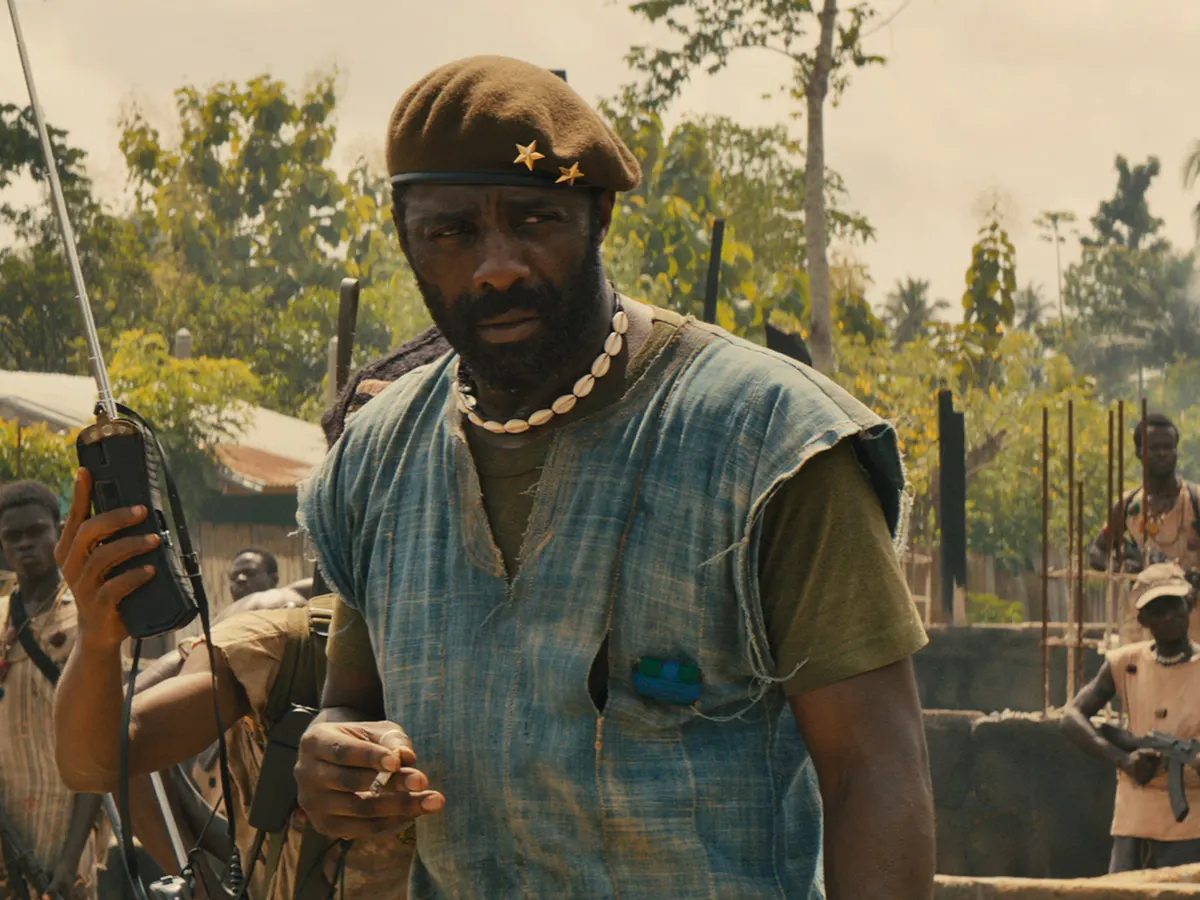If this image was part of a graphic novel, what kind of backstory would you create for the main character? In the graphic novel 'Echoes of War', Commandant was once a revered teacher in a peaceful village. The story arc unfolds as his world is torn apart by conflict, forcing him to adopt the mantle of a militant leader to protect his people. His attire, a mix of civilian and military garb, symbolizes his transition from educator to warrior. The green beret, a relic from his past life teaching about peace and leadership, now serves as a constant reminder of the stark contrast between his former ideals and his present reality. Each chapter delves into his personal struggle, balancing the harsh demands of warfare with his deep-seated desire to rebuild a society destroyed by violence and oppression. Consider the image is a keyframe in an animated series. Create a dialogue for this scene. Commandant: 'We stand on the brink of a new dawn, but we must fight to see the light. Remember, every action we take is for the future we believe in. Keep your resolve strong, and your hearts even stronger. Today, we push forward for those who cannot.'

Soldier: 'Yes, Commandant! We are with you every step of the way.'

Commandant: 'Good. Stay vigilant, stay united. Together, we are unstoppable.' 